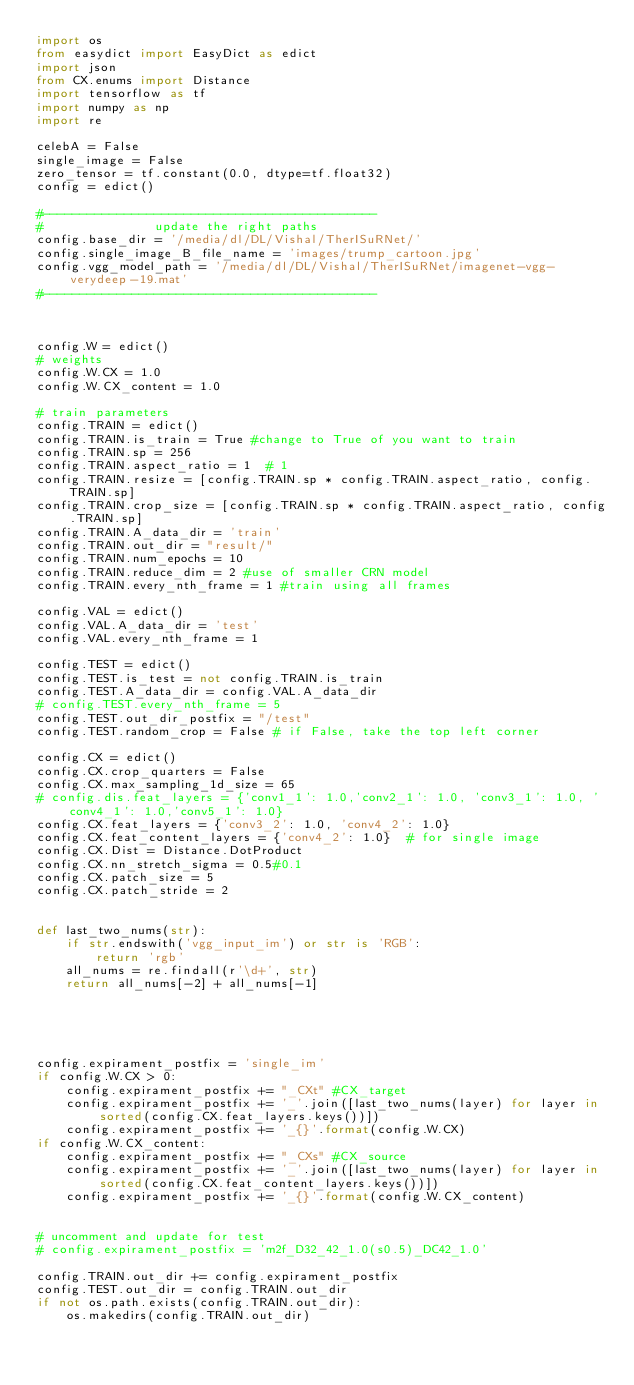<code> <loc_0><loc_0><loc_500><loc_500><_Python_>import os
from easydict import EasyDict as edict
import json
from CX.enums import Distance
import tensorflow as tf
import numpy as np
import re

celebA = False
single_image = False
zero_tensor = tf.constant(0.0, dtype=tf.float32)
config = edict()

#---------------------------------------------
#               update the right paths
config.base_dir = '/media/dl/DL/Vishal/TherISuRNet/'
config.single_image_B_file_name = 'images/trump_cartoon.jpg'
config.vgg_model_path = '/media/dl/DL/Vishal/TherISuRNet/imagenet-vgg-verydeep-19.mat'
#---------------------------------------------



config.W = edict()
# weights
config.W.CX = 1.0
config.W.CX_content = 1.0

# train parameters
config.TRAIN = edict()
config.TRAIN.is_train = True #change to True of you want to train
config.TRAIN.sp = 256
config.TRAIN.aspect_ratio = 1  # 1
config.TRAIN.resize = [config.TRAIN.sp * config.TRAIN.aspect_ratio, config.TRAIN.sp]
config.TRAIN.crop_size = [config.TRAIN.sp * config.TRAIN.aspect_ratio, config.TRAIN.sp]
config.TRAIN.A_data_dir = 'train'
config.TRAIN.out_dir = "result/"
config.TRAIN.num_epochs = 10
config.TRAIN.reduce_dim = 2 #use of smaller CRN model
config.TRAIN.every_nth_frame = 1 #train using all frames

config.VAL = edict()
config.VAL.A_data_dir = 'test'
config.VAL.every_nth_frame = 1

config.TEST = edict()
config.TEST.is_test = not config.TRAIN.is_train
config.TEST.A_data_dir = config.VAL.A_data_dir
# config.TEST.every_nth_frame = 5
config.TEST.out_dir_postfix = "/test"
config.TEST.random_crop = False # if False, take the top left corner

config.CX = edict()
config.CX.crop_quarters = False
config.CX.max_sampling_1d_size = 65
# config.dis.feat_layers = {'conv1_1': 1.0,'conv2_1': 1.0, 'conv3_1': 1.0, 'conv4_1': 1.0,'conv5_1': 1.0}
config.CX.feat_layers = {'conv3_2': 1.0, 'conv4_2': 1.0}
config.CX.feat_content_layers = {'conv4_2': 1.0}  # for single image
config.CX.Dist = Distance.DotProduct
config.CX.nn_stretch_sigma = 0.5#0.1
config.CX.patch_size = 5
config.CX.patch_stride = 2


def last_two_nums(str):
    if str.endswith('vgg_input_im') or str is 'RGB':
        return 'rgb'
    all_nums = re.findall(r'\d+', str)
    return all_nums[-2] + all_nums[-1]





config.expirament_postfix = 'single_im'
if config.W.CX > 0:
    config.expirament_postfix += "_CXt" #CX_target
    config.expirament_postfix += '_'.join([last_two_nums(layer) for layer in sorted(config.CX.feat_layers.keys())])
    config.expirament_postfix += '_{}'.format(config.W.CX)
if config.W.CX_content:
    config.expirament_postfix += "_CXs" #CX_source
    config.expirament_postfix += '_'.join([last_two_nums(layer) for layer in sorted(config.CX.feat_content_layers.keys())])
    config.expirament_postfix += '_{}'.format(config.W.CX_content)


# uncomment and update for test
# config.expirament_postfix = 'm2f_D32_42_1.0(s0.5)_DC42_1.0'

config.TRAIN.out_dir += config.expirament_postfix
config.TEST.out_dir = config.TRAIN.out_dir
if not os.path.exists(config.TRAIN.out_dir):
    os.makedirs(config.TRAIN.out_dir)


</code> 